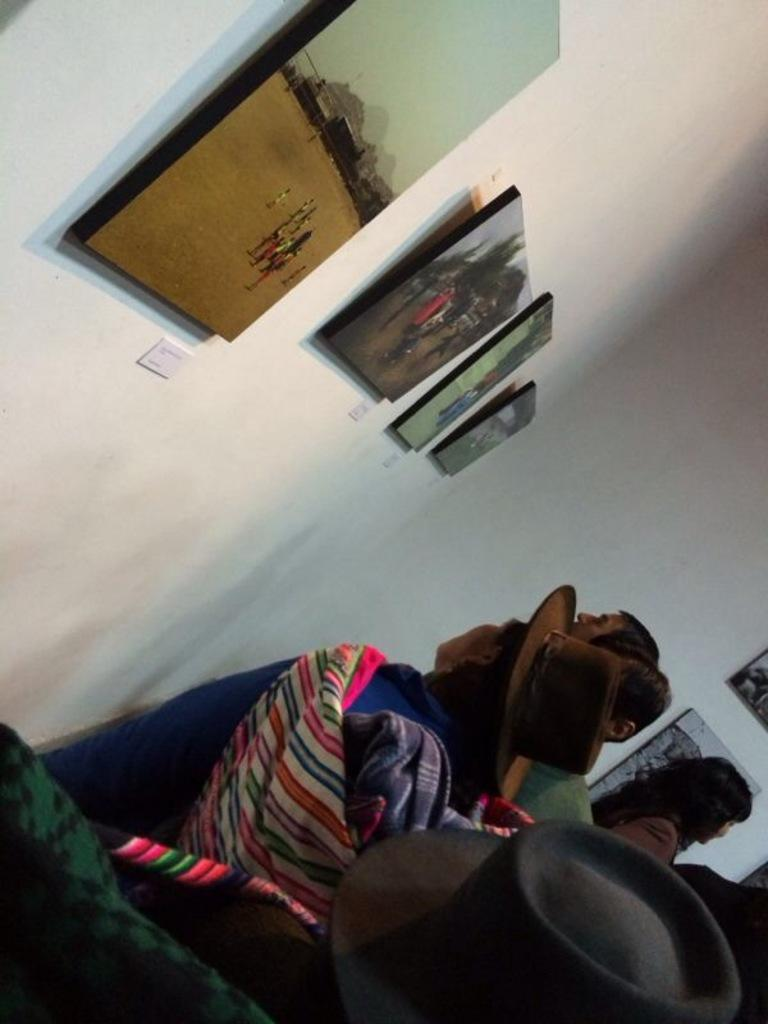What is on the wall in the image? There are frames on the wall in the image. What is happening in front of the wall? There are people standing in front of the wall in the image. What are the people doing? The people are watching something. Can you tell me what type of drum is being played by the stranger in the image? There is no drum or stranger present in the image. What angle is the camera positioned at in the image? The angle of the camera is not mentioned in the provided facts, so it cannot be determined from the image. 